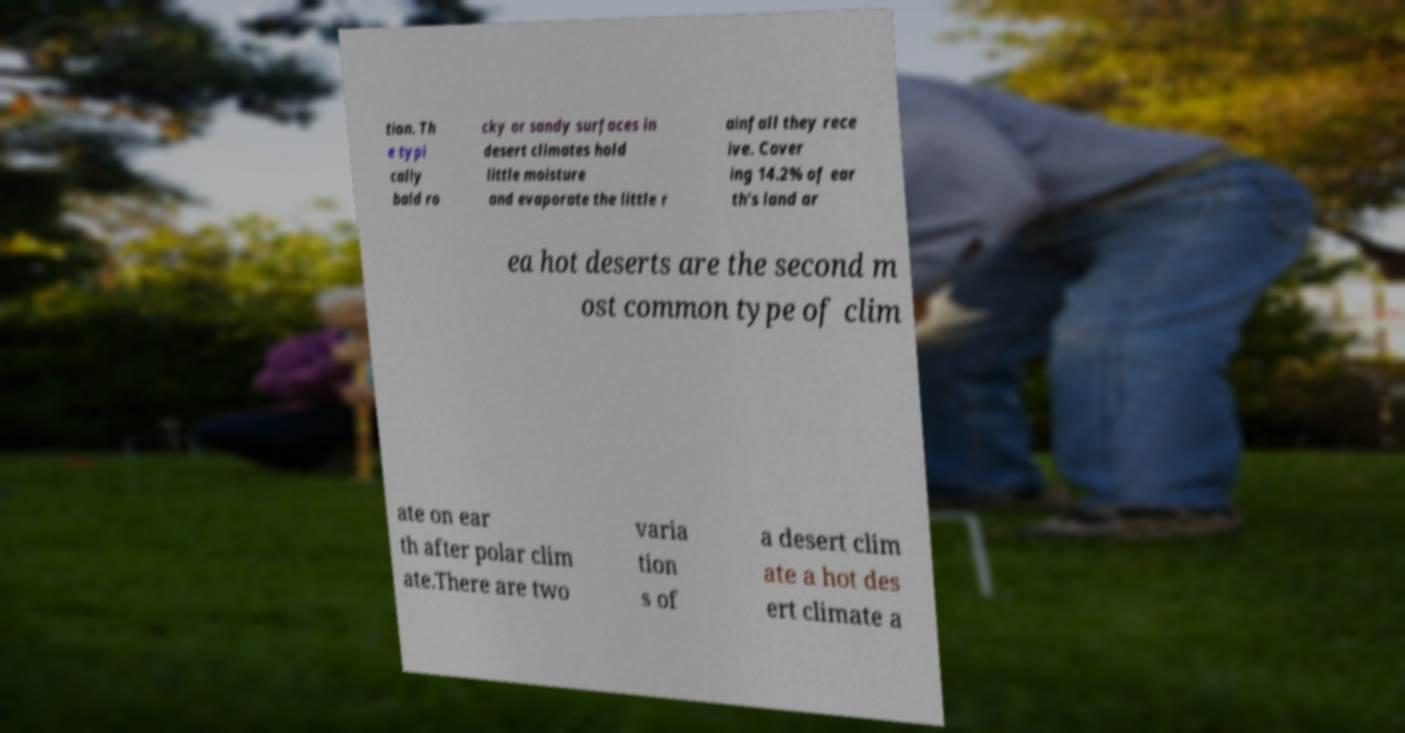Can you accurately transcribe the text from the provided image for me? tion. Th e typi cally bald ro cky or sandy surfaces in desert climates hold little moisture and evaporate the little r ainfall they rece ive. Cover ing 14.2% of ear th's land ar ea hot deserts are the second m ost common type of clim ate on ear th after polar clim ate.There are two varia tion s of a desert clim ate a hot des ert climate a 